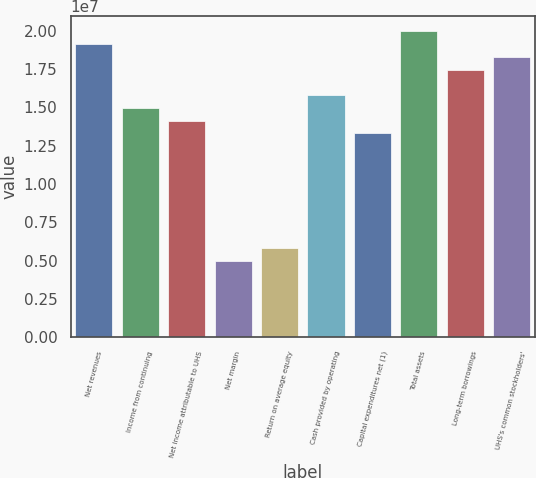<chart> <loc_0><loc_0><loc_500><loc_500><bar_chart><fcel>Net revenues<fcel>Income from continuing<fcel>Net income attributable to UHS<fcel>Net margin<fcel>Return on average equity<fcel>Cash provided by operating<fcel>Capital expenditures net (1)<fcel>Total assets<fcel>Long-term borrowings<fcel>UHS's common stockholders'<nl><fcel>1.9117e+07<fcel>1.49611e+07<fcel>1.41299e+07<fcel>4.98703e+06<fcel>5.81821e+06<fcel>1.57923e+07<fcel>1.32988e+07<fcel>1.99481e+07<fcel>1.74546e+07<fcel>1.82858e+07<nl></chart> 